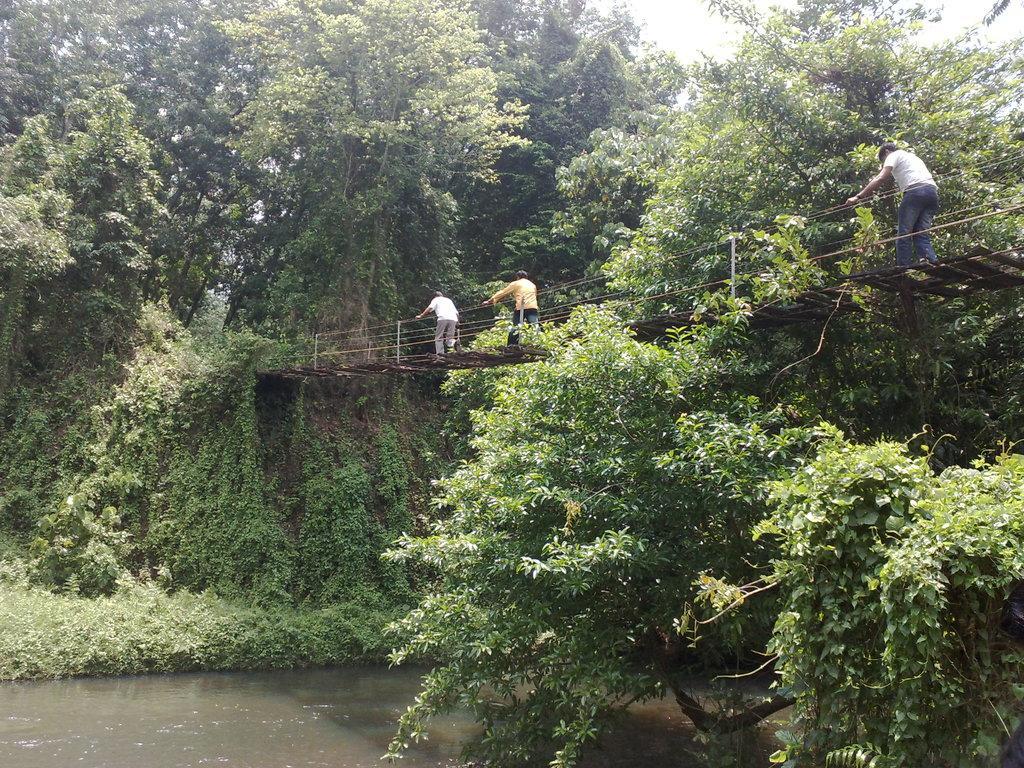In one or two sentences, can you explain what this image depicts? In the picture I can see few persons standing on a bridge and there is water under it and there are trees in the background. 